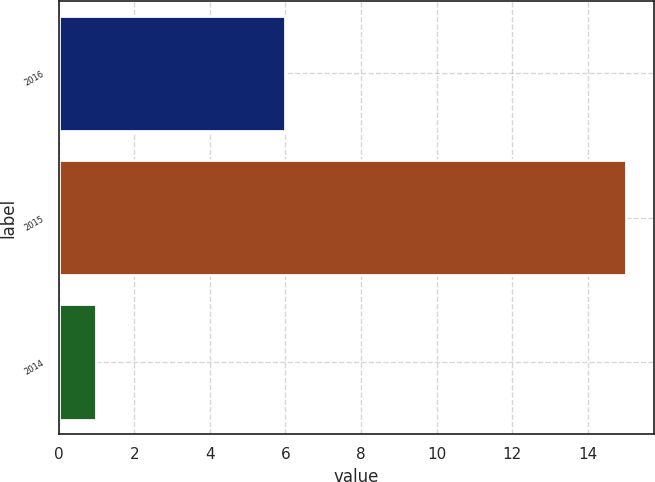Convert chart. <chart><loc_0><loc_0><loc_500><loc_500><bar_chart><fcel>2016<fcel>2015<fcel>2014<nl><fcel>6<fcel>15<fcel>1<nl></chart> 